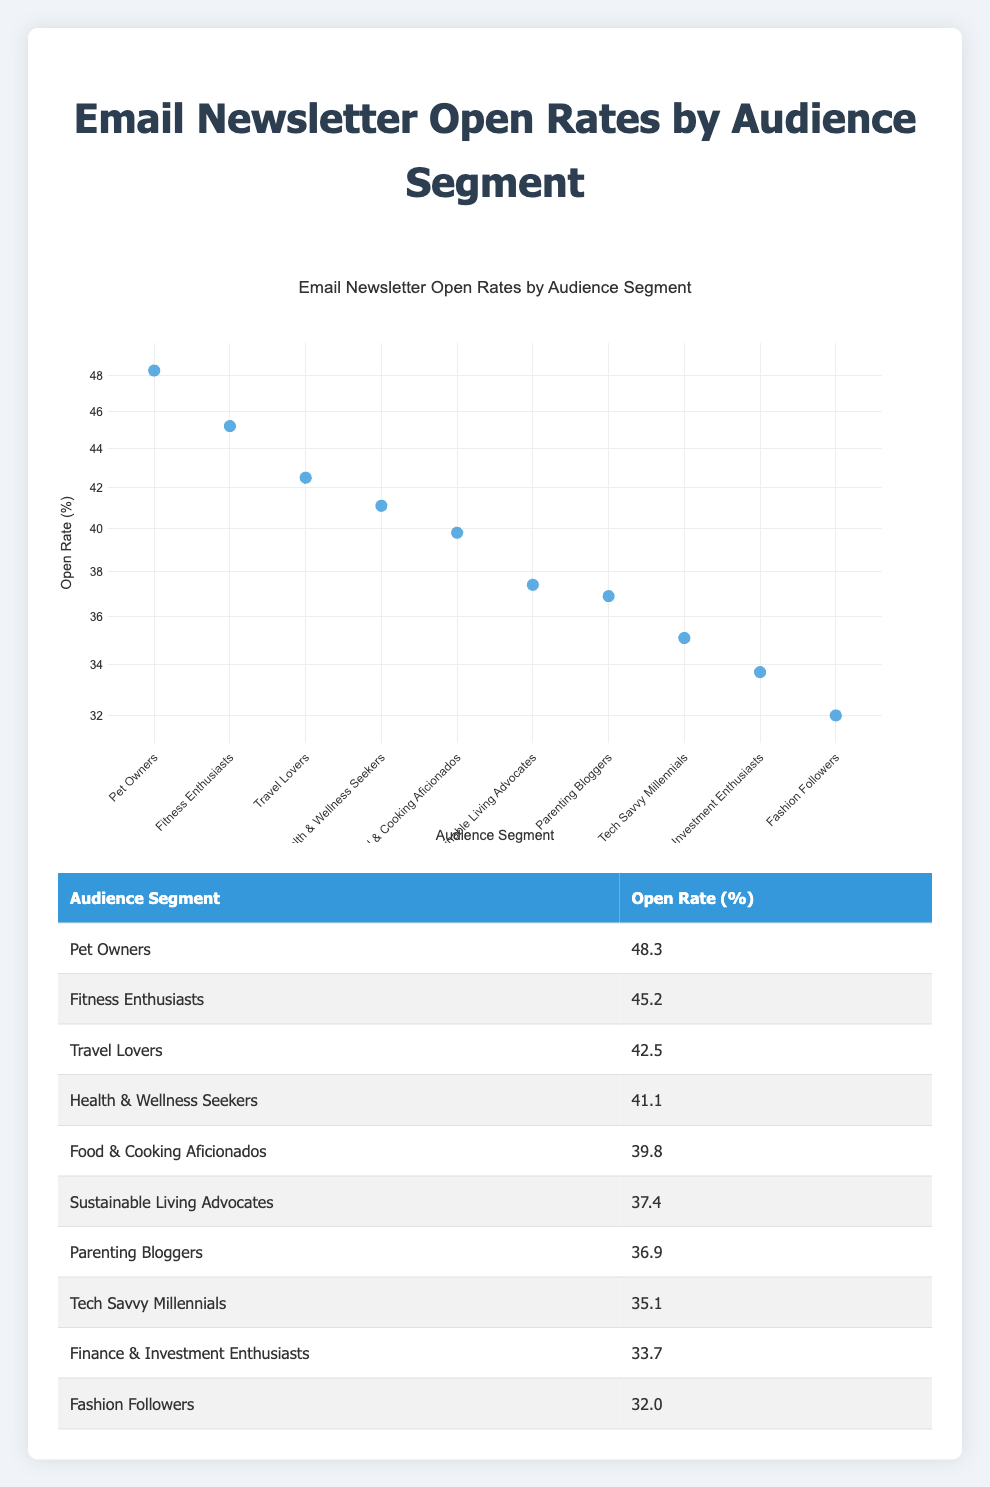What is the highest open rate among the audience segments? The table shows open rates for different audience segments. Scanning through the open rates, the highest value is 48.3 for the "Pet Owners" segment.
Answer: 48.3 Which audience segment has the lowest open rate? Looking at the table, the segment with the lowest percentage is "Fashion Followers" with an open rate of 32.0.
Answer: 32.0 What is the open rate difference between Fitness Enthusiasts and Tech Savvy Millennials? From the table, Fitness Enthusiasts have an open rate of 45.2, and Tech Savvy Millennials have 35.1. The difference is calculated as 45.2 - 35.1 = 10.1.
Answer: 10.1 Is the open rate for Health & Wellness Seekers higher than that for Food & Cooking Aficionados? Checking the open rates, Health & Wellness Seekers have an open rate of 41.1 while Food & Cooking Aficionados have 39.8. Since 41.1 is greater than 39.8, the statement is true.
Answer: Yes What is the average open rate of the segments that have an open rate above 40%? The segments with open rates above 40% are: Pet Owners (48.3), Fitness Enthusiasts (45.2), Travel Lovers (42.5), and Health & Wellness Seekers (41.1). Adding these rates gives 48.3 + 45.2 + 42.5 + 41.1 = 177.1. Dividing by the number of segments (4) gives an average of 177.1 / 4 = 44.275.
Answer: 44.275 Which two audience segments have the closest open rates? By examining the table, "Sustainable Living Advocates" has an open rate of 37.4 and "Parenting Bloggers" has 36.9, which are the closest together with only a 0.5 difference.
Answer: 0.5 What percentage of audience segments have an open rate below 40%? The segments with open rates below 40% are Tech Savvy Millennials (35.1), Finance & Investment Enthusiasts (33.7), and Fashion Followers (32.0). In total, there are 3 segments out of 10. The percentage is calculated as (3/10) * 100 = 30%.
Answer: 30% Are there more audience segments with an open rate above 40% or below 40%? Looking at the segments, those above 40% are Pet Owners, Fitness Enthusiasts, Travel Lovers, and Health & Wellness Seekers (4 segments), and those below 40% are Tech Savvy Millennials, Finance & Investment Enthusiasts, Sustainable Living Advocates, Parenting Bloggers, and Fashion Followers (6 segments). Hence, there are more below 40%.
Answer: Below 40% 